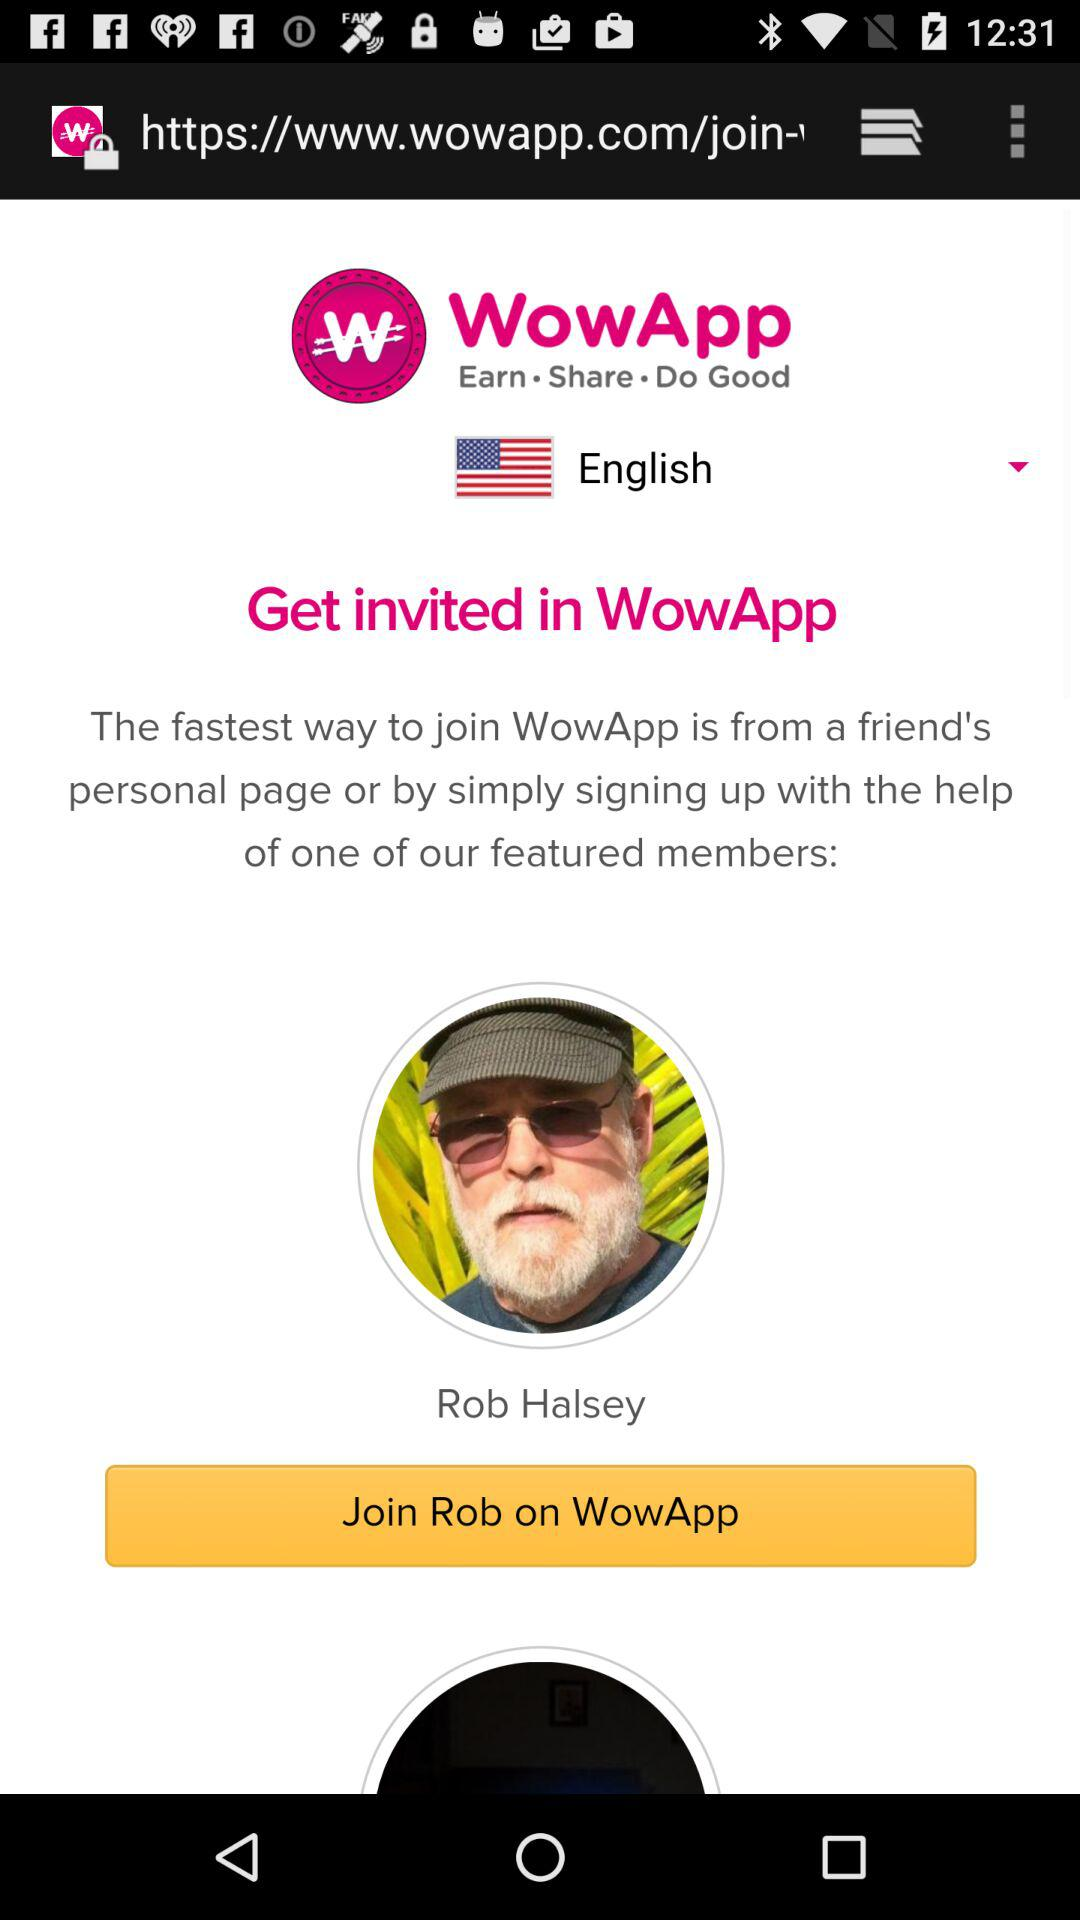What is the name of the user? The name of the user is Rob Halsey. 